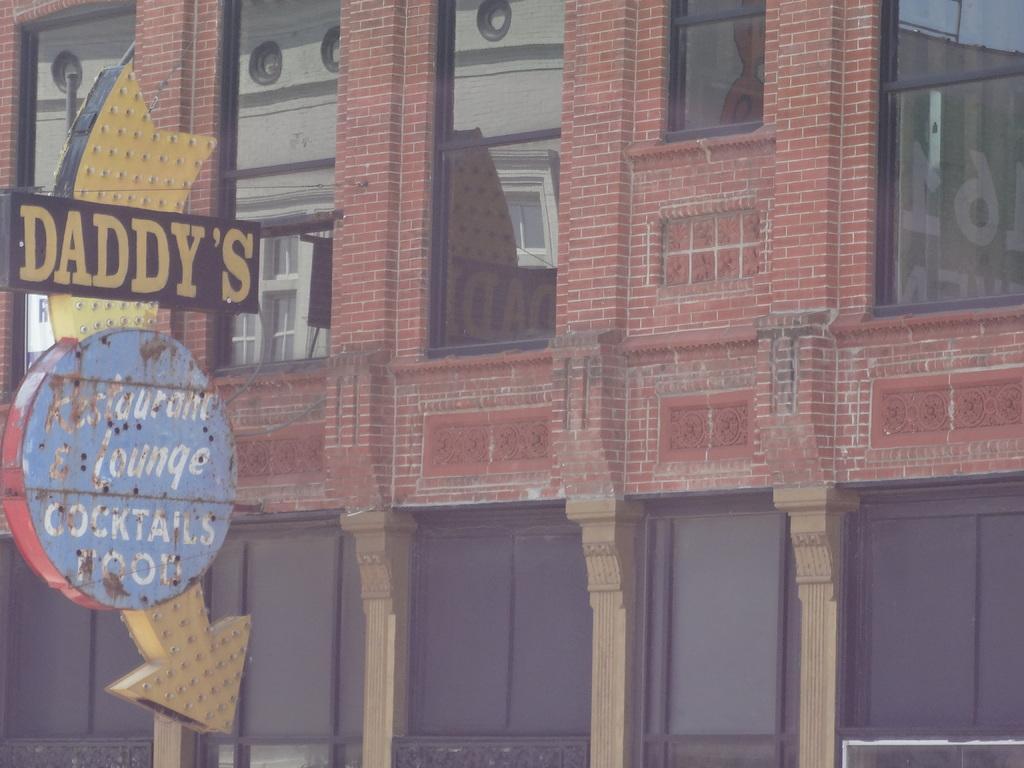Can you describe this image briefly? In this image there is a building. On the left we can see a board. There are windows. 